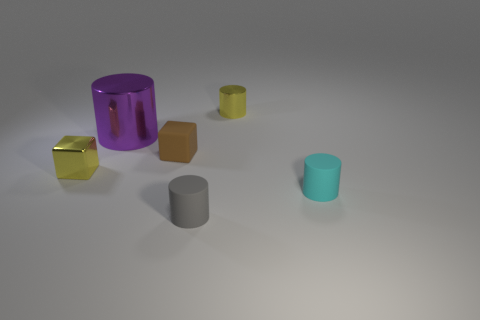Subtract all red cylinders. Subtract all green balls. How many cylinders are left? 4 Add 2 brown matte cubes. How many objects exist? 8 Subtract all cylinders. How many objects are left? 2 Add 2 purple metal things. How many purple metal things exist? 3 Subtract 0 gray blocks. How many objects are left? 6 Subtract all small shiny cubes. Subtract all big purple things. How many objects are left? 4 Add 6 large cylinders. How many large cylinders are left? 7 